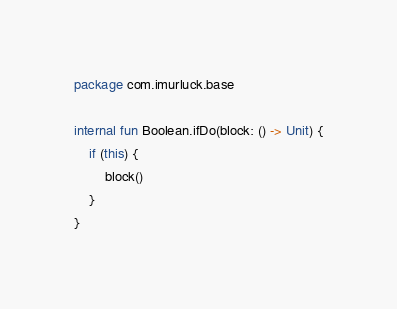Convert code to text. <code><loc_0><loc_0><loc_500><loc_500><_Kotlin_>package com.imurluck.base

internal fun Boolean.ifDo(block: () -> Unit) {
    if (this) {
        block()
    }
}</code> 